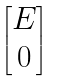<formula> <loc_0><loc_0><loc_500><loc_500>\begin{bmatrix} E \\ 0 \end{bmatrix}</formula> 